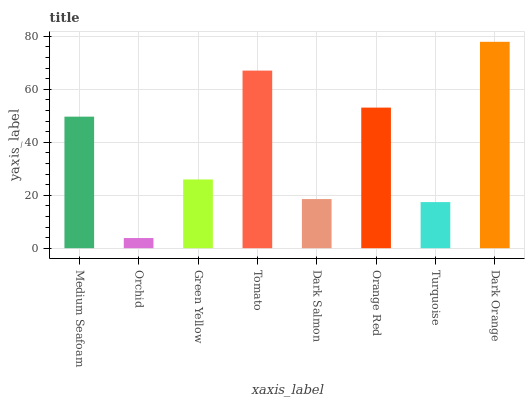Is Orchid the minimum?
Answer yes or no. Yes. Is Dark Orange the maximum?
Answer yes or no. Yes. Is Green Yellow the minimum?
Answer yes or no. No. Is Green Yellow the maximum?
Answer yes or no. No. Is Green Yellow greater than Orchid?
Answer yes or no. Yes. Is Orchid less than Green Yellow?
Answer yes or no. Yes. Is Orchid greater than Green Yellow?
Answer yes or no. No. Is Green Yellow less than Orchid?
Answer yes or no. No. Is Medium Seafoam the high median?
Answer yes or no. Yes. Is Green Yellow the low median?
Answer yes or no. Yes. Is Orchid the high median?
Answer yes or no. No. Is Dark Salmon the low median?
Answer yes or no. No. 